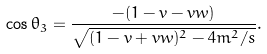Convert formula to latex. <formula><loc_0><loc_0><loc_500><loc_500>\cos \theta _ { 3 } = \frac { - ( 1 - v - v w ) } { \sqrt { ( 1 - v + v w ) ^ { 2 } - 4 m ^ { 2 } / s } } .</formula> 